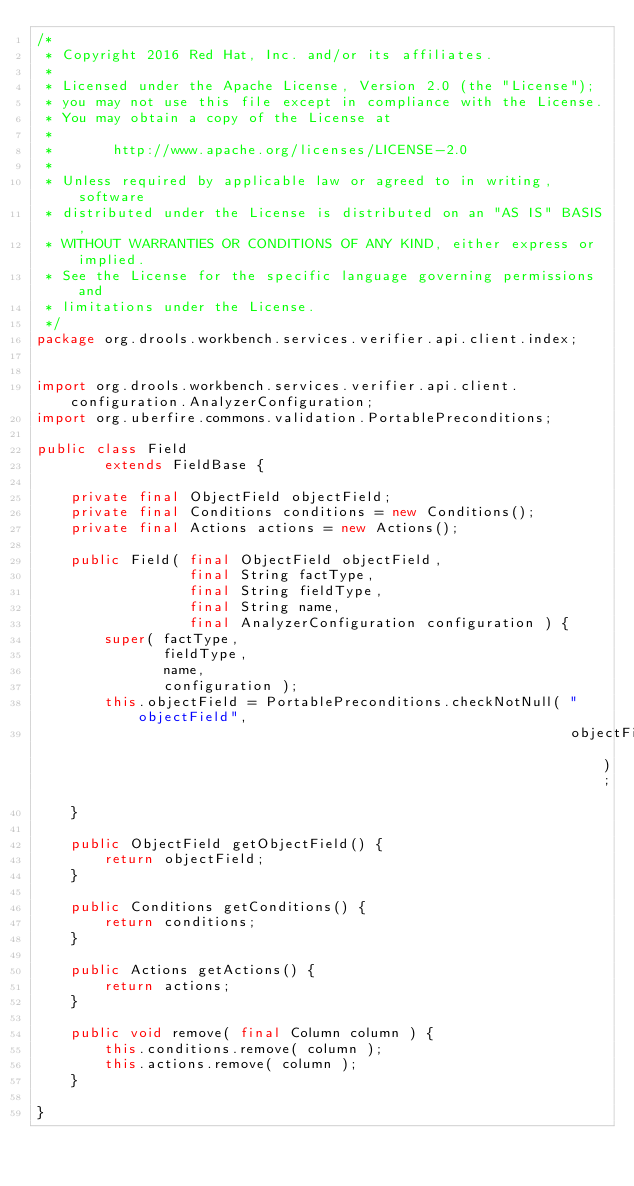Convert code to text. <code><loc_0><loc_0><loc_500><loc_500><_Java_>/*
 * Copyright 2016 Red Hat, Inc. and/or its affiliates.
 *
 * Licensed under the Apache License, Version 2.0 (the "License");
 * you may not use this file except in compliance with the License.
 * You may obtain a copy of the License at
 *
 *       http://www.apache.org/licenses/LICENSE-2.0
 *
 * Unless required by applicable law or agreed to in writing, software
 * distributed under the License is distributed on an "AS IS" BASIS,
 * WITHOUT WARRANTIES OR CONDITIONS OF ANY KIND, either express or implied.
 * See the License for the specific language governing permissions and
 * limitations under the License.
 */
package org.drools.workbench.services.verifier.api.client.index;


import org.drools.workbench.services.verifier.api.client.configuration.AnalyzerConfiguration;
import org.uberfire.commons.validation.PortablePreconditions;

public class Field
        extends FieldBase {

    private final ObjectField objectField;
    private final Conditions conditions = new Conditions();
    private final Actions actions = new Actions();

    public Field( final ObjectField objectField,
                  final String factType,
                  final String fieldType,
                  final String name,
                  final AnalyzerConfiguration configuration ) {
        super( factType,
               fieldType,
               name,
               configuration );
        this.objectField = PortablePreconditions.checkNotNull( "objectField",
                                                               objectField );
    }

    public ObjectField getObjectField() {
        return objectField;
    }

    public Conditions getConditions() {
        return conditions;
    }

    public Actions getActions() {
        return actions;
    }

    public void remove( final Column column ) {
        this.conditions.remove( column );
        this.actions.remove( column );
    }

}
</code> 